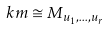Convert formula to latex. <formula><loc_0><loc_0><loc_500><loc_500>\ k m \cong M _ { u _ { 1 } , \dots , u _ { r } }</formula> 